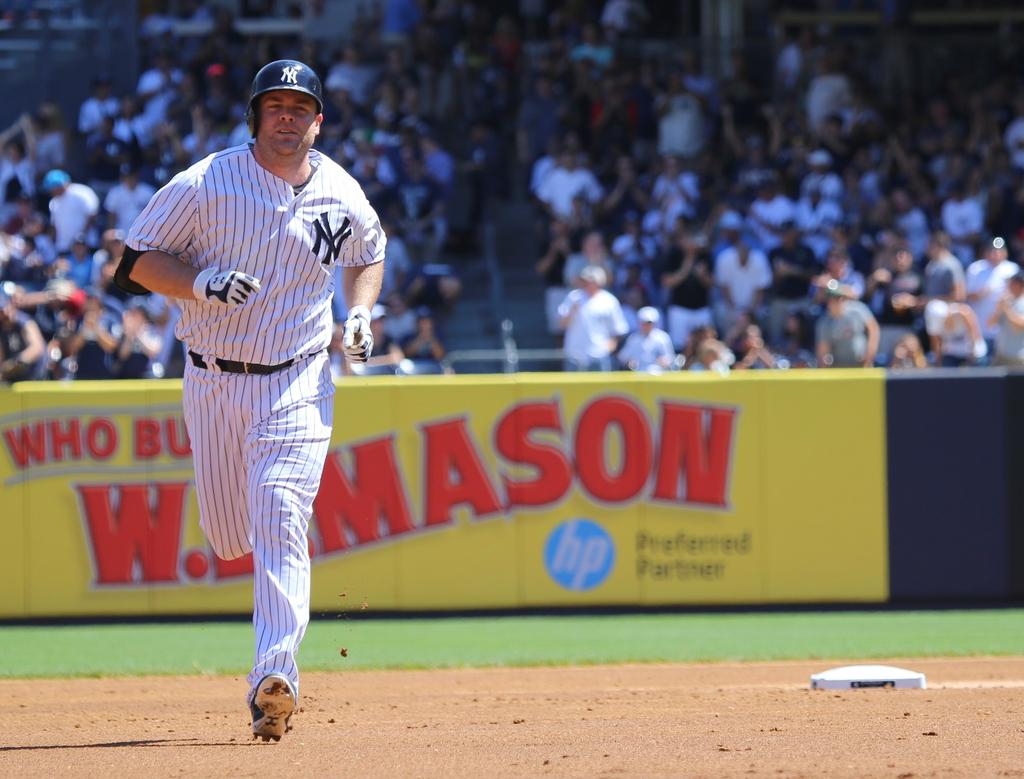What is on the jersey?
Make the answer very short. Ny. 